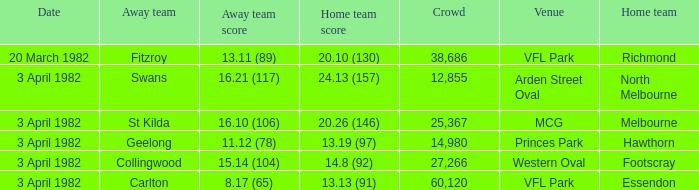What score did the home team of north melbourne get? 24.13 (157). 